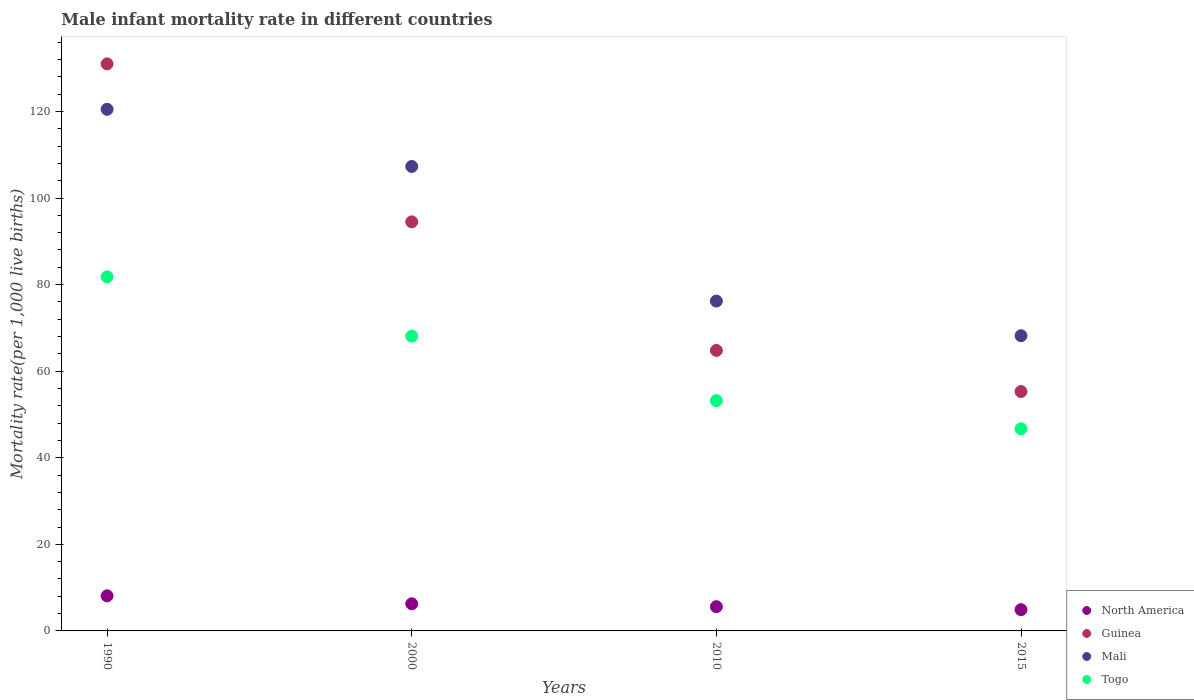How many different coloured dotlines are there?
Ensure brevity in your answer.  4. What is the male infant mortality rate in Mali in 2000?
Provide a succinct answer. 107.3. Across all years, what is the maximum male infant mortality rate in Togo?
Your answer should be compact. 81.8. Across all years, what is the minimum male infant mortality rate in North America?
Your response must be concise. 4.91. In which year was the male infant mortality rate in North America maximum?
Give a very brief answer. 1990. In which year was the male infant mortality rate in North America minimum?
Make the answer very short. 2015. What is the total male infant mortality rate in Mali in the graph?
Your answer should be very brief. 372.2. What is the difference between the male infant mortality rate in Guinea in 2000 and the male infant mortality rate in North America in 2010?
Give a very brief answer. 88.9. What is the average male infant mortality rate in Togo per year?
Your answer should be compact. 62.45. In the year 2015, what is the difference between the male infant mortality rate in North America and male infant mortality rate in Guinea?
Your answer should be very brief. -50.39. What is the ratio of the male infant mortality rate in Togo in 2010 to that in 2015?
Keep it short and to the point. 1.14. Is the difference between the male infant mortality rate in North America in 1990 and 2000 greater than the difference between the male infant mortality rate in Guinea in 1990 and 2000?
Your response must be concise. No. What is the difference between the highest and the second highest male infant mortality rate in Togo?
Ensure brevity in your answer.  13.7. What is the difference between the highest and the lowest male infant mortality rate in Mali?
Make the answer very short. 52.3. Is the sum of the male infant mortality rate in Togo in 2000 and 2010 greater than the maximum male infant mortality rate in North America across all years?
Ensure brevity in your answer.  Yes. Is it the case that in every year, the sum of the male infant mortality rate in Guinea and male infant mortality rate in North America  is greater than the male infant mortality rate in Mali?
Your answer should be compact. No. Does the male infant mortality rate in Guinea monotonically increase over the years?
Make the answer very short. No. How many years are there in the graph?
Your answer should be compact. 4. Does the graph contain grids?
Your answer should be compact. No. What is the title of the graph?
Keep it short and to the point. Male infant mortality rate in different countries. What is the label or title of the X-axis?
Make the answer very short. Years. What is the label or title of the Y-axis?
Provide a short and direct response. Mortality rate(per 1,0 live births). What is the Mortality rate(per 1,000 live births) of North America in 1990?
Provide a succinct answer. 8.11. What is the Mortality rate(per 1,000 live births) of Guinea in 1990?
Provide a short and direct response. 131. What is the Mortality rate(per 1,000 live births) in Mali in 1990?
Give a very brief answer. 120.5. What is the Mortality rate(per 1,000 live births) of Togo in 1990?
Ensure brevity in your answer.  81.8. What is the Mortality rate(per 1,000 live births) of North America in 2000?
Ensure brevity in your answer.  6.27. What is the Mortality rate(per 1,000 live births) in Guinea in 2000?
Make the answer very short. 94.5. What is the Mortality rate(per 1,000 live births) in Mali in 2000?
Offer a terse response. 107.3. What is the Mortality rate(per 1,000 live births) in Togo in 2000?
Provide a succinct answer. 68.1. What is the Mortality rate(per 1,000 live births) in North America in 2010?
Ensure brevity in your answer.  5.6. What is the Mortality rate(per 1,000 live births) of Guinea in 2010?
Ensure brevity in your answer.  64.8. What is the Mortality rate(per 1,000 live births) of Mali in 2010?
Provide a short and direct response. 76.2. What is the Mortality rate(per 1,000 live births) of Togo in 2010?
Provide a short and direct response. 53.2. What is the Mortality rate(per 1,000 live births) in North America in 2015?
Make the answer very short. 4.91. What is the Mortality rate(per 1,000 live births) of Guinea in 2015?
Keep it short and to the point. 55.3. What is the Mortality rate(per 1,000 live births) of Mali in 2015?
Provide a succinct answer. 68.2. What is the Mortality rate(per 1,000 live births) of Togo in 2015?
Keep it short and to the point. 46.7. Across all years, what is the maximum Mortality rate(per 1,000 live births) in North America?
Ensure brevity in your answer.  8.11. Across all years, what is the maximum Mortality rate(per 1,000 live births) in Guinea?
Your answer should be compact. 131. Across all years, what is the maximum Mortality rate(per 1,000 live births) of Mali?
Offer a terse response. 120.5. Across all years, what is the maximum Mortality rate(per 1,000 live births) in Togo?
Your answer should be compact. 81.8. Across all years, what is the minimum Mortality rate(per 1,000 live births) in North America?
Make the answer very short. 4.91. Across all years, what is the minimum Mortality rate(per 1,000 live births) in Guinea?
Give a very brief answer. 55.3. Across all years, what is the minimum Mortality rate(per 1,000 live births) of Mali?
Offer a terse response. 68.2. Across all years, what is the minimum Mortality rate(per 1,000 live births) in Togo?
Provide a succinct answer. 46.7. What is the total Mortality rate(per 1,000 live births) of North America in the graph?
Provide a short and direct response. 24.89. What is the total Mortality rate(per 1,000 live births) in Guinea in the graph?
Offer a very short reply. 345.6. What is the total Mortality rate(per 1,000 live births) in Mali in the graph?
Your answer should be compact. 372.2. What is the total Mortality rate(per 1,000 live births) in Togo in the graph?
Offer a very short reply. 249.8. What is the difference between the Mortality rate(per 1,000 live births) of North America in 1990 and that in 2000?
Offer a terse response. 1.84. What is the difference between the Mortality rate(per 1,000 live births) of Guinea in 1990 and that in 2000?
Your response must be concise. 36.5. What is the difference between the Mortality rate(per 1,000 live births) of North America in 1990 and that in 2010?
Your answer should be compact. 2.51. What is the difference between the Mortality rate(per 1,000 live births) of Guinea in 1990 and that in 2010?
Keep it short and to the point. 66.2. What is the difference between the Mortality rate(per 1,000 live births) of Mali in 1990 and that in 2010?
Make the answer very short. 44.3. What is the difference between the Mortality rate(per 1,000 live births) in Togo in 1990 and that in 2010?
Your answer should be compact. 28.6. What is the difference between the Mortality rate(per 1,000 live births) of North America in 1990 and that in 2015?
Your answer should be compact. 3.19. What is the difference between the Mortality rate(per 1,000 live births) of Guinea in 1990 and that in 2015?
Your response must be concise. 75.7. What is the difference between the Mortality rate(per 1,000 live births) in Mali in 1990 and that in 2015?
Make the answer very short. 52.3. What is the difference between the Mortality rate(per 1,000 live births) of Togo in 1990 and that in 2015?
Keep it short and to the point. 35.1. What is the difference between the Mortality rate(per 1,000 live births) in North America in 2000 and that in 2010?
Ensure brevity in your answer.  0.67. What is the difference between the Mortality rate(per 1,000 live births) of Guinea in 2000 and that in 2010?
Your answer should be very brief. 29.7. What is the difference between the Mortality rate(per 1,000 live births) of Mali in 2000 and that in 2010?
Your response must be concise. 31.1. What is the difference between the Mortality rate(per 1,000 live births) in Togo in 2000 and that in 2010?
Offer a very short reply. 14.9. What is the difference between the Mortality rate(per 1,000 live births) of North America in 2000 and that in 2015?
Ensure brevity in your answer.  1.36. What is the difference between the Mortality rate(per 1,000 live births) in Guinea in 2000 and that in 2015?
Provide a short and direct response. 39.2. What is the difference between the Mortality rate(per 1,000 live births) of Mali in 2000 and that in 2015?
Provide a short and direct response. 39.1. What is the difference between the Mortality rate(per 1,000 live births) in Togo in 2000 and that in 2015?
Your response must be concise. 21.4. What is the difference between the Mortality rate(per 1,000 live births) of North America in 2010 and that in 2015?
Offer a very short reply. 0.69. What is the difference between the Mortality rate(per 1,000 live births) of Guinea in 2010 and that in 2015?
Your answer should be very brief. 9.5. What is the difference between the Mortality rate(per 1,000 live births) in North America in 1990 and the Mortality rate(per 1,000 live births) in Guinea in 2000?
Your answer should be compact. -86.39. What is the difference between the Mortality rate(per 1,000 live births) of North America in 1990 and the Mortality rate(per 1,000 live births) of Mali in 2000?
Your answer should be compact. -99.19. What is the difference between the Mortality rate(per 1,000 live births) of North America in 1990 and the Mortality rate(per 1,000 live births) of Togo in 2000?
Ensure brevity in your answer.  -59.99. What is the difference between the Mortality rate(per 1,000 live births) of Guinea in 1990 and the Mortality rate(per 1,000 live births) of Mali in 2000?
Make the answer very short. 23.7. What is the difference between the Mortality rate(per 1,000 live births) in Guinea in 1990 and the Mortality rate(per 1,000 live births) in Togo in 2000?
Your answer should be compact. 62.9. What is the difference between the Mortality rate(per 1,000 live births) of Mali in 1990 and the Mortality rate(per 1,000 live births) of Togo in 2000?
Ensure brevity in your answer.  52.4. What is the difference between the Mortality rate(per 1,000 live births) of North America in 1990 and the Mortality rate(per 1,000 live births) of Guinea in 2010?
Your response must be concise. -56.69. What is the difference between the Mortality rate(per 1,000 live births) of North America in 1990 and the Mortality rate(per 1,000 live births) of Mali in 2010?
Offer a very short reply. -68.09. What is the difference between the Mortality rate(per 1,000 live births) in North America in 1990 and the Mortality rate(per 1,000 live births) in Togo in 2010?
Ensure brevity in your answer.  -45.09. What is the difference between the Mortality rate(per 1,000 live births) of Guinea in 1990 and the Mortality rate(per 1,000 live births) of Mali in 2010?
Offer a terse response. 54.8. What is the difference between the Mortality rate(per 1,000 live births) in Guinea in 1990 and the Mortality rate(per 1,000 live births) in Togo in 2010?
Keep it short and to the point. 77.8. What is the difference between the Mortality rate(per 1,000 live births) in Mali in 1990 and the Mortality rate(per 1,000 live births) in Togo in 2010?
Offer a terse response. 67.3. What is the difference between the Mortality rate(per 1,000 live births) in North America in 1990 and the Mortality rate(per 1,000 live births) in Guinea in 2015?
Offer a very short reply. -47.19. What is the difference between the Mortality rate(per 1,000 live births) of North America in 1990 and the Mortality rate(per 1,000 live births) of Mali in 2015?
Your answer should be very brief. -60.09. What is the difference between the Mortality rate(per 1,000 live births) in North America in 1990 and the Mortality rate(per 1,000 live births) in Togo in 2015?
Provide a short and direct response. -38.59. What is the difference between the Mortality rate(per 1,000 live births) in Guinea in 1990 and the Mortality rate(per 1,000 live births) in Mali in 2015?
Your answer should be very brief. 62.8. What is the difference between the Mortality rate(per 1,000 live births) of Guinea in 1990 and the Mortality rate(per 1,000 live births) of Togo in 2015?
Offer a terse response. 84.3. What is the difference between the Mortality rate(per 1,000 live births) in Mali in 1990 and the Mortality rate(per 1,000 live births) in Togo in 2015?
Keep it short and to the point. 73.8. What is the difference between the Mortality rate(per 1,000 live births) in North America in 2000 and the Mortality rate(per 1,000 live births) in Guinea in 2010?
Keep it short and to the point. -58.53. What is the difference between the Mortality rate(per 1,000 live births) of North America in 2000 and the Mortality rate(per 1,000 live births) of Mali in 2010?
Your answer should be compact. -69.93. What is the difference between the Mortality rate(per 1,000 live births) in North America in 2000 and the Mortality rate(per 1,000 live births) in Togo in 2010?
Keep it short and to the point. -46.93. What is the difference between the Mortality rate(per 1,000 live births) in Guinea in 2000 and the Mortality rate(per 1,000 live births) in Togo in 2010?
Provide a succinct answer. 41.3. What is the difference between the Mortality rate(per 1,000 live births) of Mali in 2000 and the Mortality rate(per 1,000 live births) of Togo in 2010?
Make the answer very short. 54.1. What is the difference between the Mortality rate(per 1,000 live births) of North America in 2000 and the Mortality rate(per 1,000 live births) of Guinea in 2015?
Make the answer very short. -49.03. What is the difference between the Mortality rate(per 1,000 live births) in North America in 2000 and the Mortality rate(per 1,000 live births) in Mali in 2015?
Ensure brevity in your answer.  -61.93. What is the difference between the Mortality rate(per 1,000 live births) of North America in 2000 and the Mortality rate(per 1,000 live births) of Togo in 2015?
Offer a very short reply. -40.43. What is the difference between the Mortality rate(per 1,000 live births) of Guinea in 2000 and the Mortality rate(per 1,000 live births) of Mali in 2015?
Your answer should be very brief. 26.3. What is the difference between the Mortality rate(per 1,000 live births) of Guinea in 2000 and the Mortality rate(per 1,000 live births) of Togo in 2015?
Provide a succinct answer. 47.8. What is the difference between the Mortality rate(per 1,000 live births) in Mali in 2000 and the Mortality rate(per 1,000 live births) in Togo in 2015?
Ensure brevity in your answer.  60.6. What is the difference between the Mortality rate(per 1,000 live births) in North America in 2010 and the Mortality rate(per 1,000 live births) in Guinea in 2015?
Provide a succinct answer. -49.7. What is the difference between the Mortality rate(per 1,000 live births) of North America in 2010 and the Mortality rate(per 1,000 live births) of Mali in 2015?
Your response must be concise. -62.6. What is the difference between the Mortality rate(per 1,000 live births) of North America in 2010 and the Mortality rate(per 1,000 live births) of Togo in 2015?
Provide a short and direct response. -41.1. What is the difference between the Mortality rate(per 1,000 live births) in Guinea in 2010 and the Mortality rate(per 1,000 live births) in Mali in 2015?
Your response must be concise. -3.4. What is the difference between the Mortality rate(per 1,000 live births) of Guinea in 2010 and the Mortality rate(per 1,000 live births) of Togo in 2015?
Offer a very short reply. 18.1. What is the difference between the Mortality rate(per 1,000 live births) in Mali in 2010 and the Mortality rate(per 1,000 live births) in Togo in 2015?
Give a very brief answer. 29.5. What is the average Mortality rate(per 1,000 live births) of North America per year?
Give a very brief answer. 6.22. What is the average Mortality rate(per 1,000 live births) in Guinea per year?
Provide a short and direct response. 86.4. What is the average Mortality rate(per 1,000 live births) of Mali per year?
Provide a succinct answer. 93.05. What is the average Mortality rate(per 1,000 live births) in Togo per year?
Give a very brief answer. 62.45. In the year 1990, what is the difference between the Mortality rate(per 1,000 live births) in North America and Mortality rate(per 1,000 live births) in Guinea?
Keep it short and to the point. -122.89. In the year 1990, what is the difference between the Mortality rate(per 1,000 live births) of North America and Mortality rate(per 1,000 live births) of Mali?
Your answer should be compact. -112.39. In the year 1990, what is the difference between the Mortality rate(per 1,000 live births) of North America and Mortality rate(per 1,000 live births) of Togo?
Your answer should be very brief. -73.69. In the year 1990, what is the difference between the Mortality rate(per 1,000 live births) of Guinea and Mortality rate(per 1,000 live births) of Togo?
Provide a short and direct response. 49.2. In the year 1990, what is the difference between the Mortality rate(per 1,000 live births) in Mali and Mortality rate(per 1,000 live births) in Togo?
Keep it short and to the point. 38.7. In the year 2000, what is the difference between the Mortality rate(per 1,000 live births) of North America and Mortality rate(per 1,000 live births) of Guinea?
Give a very brief answer. -88.23. In the year 2000, what is the difference between the Mortality rate(per 1,000 live births) in North America and Mortality rate(per 1,000 live births) in Mali?
Ensure brevity in your answer.  -101.03. In the year 2000, what is the difference between the Mortality rate(per 1,000 live births) in North America and Mortality rate(per 1,000 live births) in Togo?
Give a very brief answer. -61.83. In the year 2000, what is the difference between the Mortality rate(per 1,000 live births) of Guinea and Mortality rate(per 1,000 live births) of Togo?
Ensure brevity in your answer.  26.4. In the year 2000, what is the difference between the Mortality rate(per 1,000 live births) in Mali and Mortality rate(per 1,000 live births) in Togo?
Your answer should be compact. 39.2. In the year 2010, what is the difference between the Mortality rate(per 1,000 live births) in North America and Mortality rate(per 1,000 live births) in Guinea?
Your answer should be very brief. -59.2. In the year 2010, what is the difference between the Mortality rate(per 1,000 live births) in North America and Mortality rate(per 1,000 live births) in Mali?
Offer a very short reply. -70.6. In the year 2010, what is the difference between the Mortality rate(per 1,000 live births) in North America and Mortality rate(per 1,000 live births) in Togo?
Ensure brevity in your answer.  -47.6. In the year 2010, what is the difference between the Mortality rate(per 1,000 live births) of Mali and Mortality rate(per 1,000 live births) of Togo?
Your answer should be compact. 23. In the year 2015, what is the difference between the Mortality rate(per 1,000 live births) in North America and Mortality rate(per 1,000 live births) in Guinea?
Make the answer very short. -50.39. In the year 2015, what is the difference between the Mortality rate(per 1,000 live births) in North America and Mortality rate(per 1,000 live births) in Mali?
Ensure brevity in your answer.  -63.29. In the year 2015, what is the difference between the Mortality rate(per 1,000 live births) in North America and Mortality rate(per 1,000 live births) in Togo?
Your answer should be compact. -41.79. In the year 2015, what is the difference between the Mortality rate(per 1,000 live births) in Guinea and Mortality rate(per 1,000 live births) in Mali?
Keep it short and to the point. -12.9. In the year 2015, what is the difference between the Mortality rate(per 1,000 live births) of Guinea and Mortality rate(per 1,000 live births) of Togo?
Offer a terse response. 8.6. What is the ratio of the Mortality rate(per 1,000 live births) in North America in 1990 to that in 2000?
Provide a short and direct response. 1.29. What is the ratio of the Mortality rate(per 1,000 live births) of Guinea in 1990 to that in 2000?
Your answer should be compact. 1.39. What is the ratio of the Mortality rate(per 1,000 live births) in Mali in 1990 to that in 2000?
Your answer should be very brief. 1.12. What is the ratio of the Mortality rate(per 1,000 live births) of Togo in 1990 to that in 2000?
Make the answer very short. 1.2. What is the ratio of the Mortality rate(per 1,000 live births) in North America in 1990 to that in 2010?
Ensure brevity in your answer.  1.45. What is the ratio of the Mortality rate(per 1,000 live births) of Guinea in 1990 to that in 2010?
Make the answer very short. 2.02. What is the ratio of the Mortality rate(per 1,000 live births) in Mali in 1990 to that in 2010?
Make the answer very short. 1.58. What is the ratio of the Mortality rate(per 1,000 live births) in Togo in 1990 to that in 2010?
Your answer should be very brief. 1.54. What is the ratio of the Mortality rate(per 1,000 live births) in North America in 1990 to that in 2015?
Ensure brevity in your answer.  1.65. What is the ratio of the Mortality rate(per 1,000 live births) in Guinea in 1990 to that in 2015?
Make the answer very short. 2.37. What is the ratio of the Mortality rate(per 1,000 live births) of Mali in 1990 to that in 2015?
Make the answer very short. 1.77. What is the ratio of the Mortality rate(per 1,000 live births) in Togo in 1990 to that in 2015?
Your answer should be compact. 1.75. What is the ratio of the Mortality rate(per 1,000 live births) of North America in 2000 to that in 2010?
Offer a terse response. 1.12. What is the ratio of the Mortality rate(per 1,000 live births) of Guinea in 2000 to that in 2010?
Make the answer very short. 1.46. What is the ratio of the Mortality rate(per 1,000 live births) of Mali in 2000 to that in 2010?
Your answer should be compact. 1.41. What is the ratio of the Mortality rate(per 1,000 live births) in Togo in 2000 to that in 2010?
Offer a terse response. 1.28. What is the ratio of the Mortality rate(per 1,000 live births) in North America in 2000 to that in 2015?
Offer a very short reply. 1.28. What is the ratio of the Mortality rate(per 1,000 live births) of Guinea in 2000 to that in 2015?
Offer a very short reply. 1.71. What is the ratio of the Mortality rate(per 1,000 live births) in Mali in 2000 to that in 2015?
Provide a short and direct response. 1.57. What is the ratio of the Mortality rate(per 1,000 live births) in Togo in 2000 to that in 2015?
Offer a very short reply. 1.46. What is the ratio of the Mortality rate(per 1,000 live births) of North America in 2010 to that in 2015?
Your answer should be very brief. 1.14. What is the ratio of the Mortality rate(per 1,000 live births) of Guinea in 2010 to that in 2015?
Your response must be concise. 1.17. What is the ratio of the Mortality rate(per 1,000 live births) in Mali in 2010 to that in 2015?
Offer a very short reply. 1.12. What is the ratio of the Mortality rate(per 1,000 live births) in Togo in 2010 to that in 2015?
Your answer should be compact. 1.14. What is the difference between the highest and the second highest Mortality rate(per 1,000 live births) of North America?
Offer a terse response. 1.84. What is the difference between the highest and the second highest Mortality rate(per 1,000 live births) in Guinea?
Provide a succinct answer. 36.5. What is the difference between the highest and the second highest Mortality rate(per 1,000 live births) in Mali?
Provide a short and direct response. 13.2. What is the difference between the highest and the lowest Mortality rate(per 1,000 live births) in North America?
Provide a short and direct response. 3.19. What is the difference between the highest and the lowest Mortality rate(per 1,000 live births) of Guinea?
Make the answer very short. 75.7. What is the difference between the highest and the lowest Mortality rate(per 1,000 live births) in Mali?
Provide a succinct answer. 52.3. What is the difference between the highest and the lowest Mortality rate(per 1,000 live births) in Togo?
Ensure brevity in your answer.  35.1. 